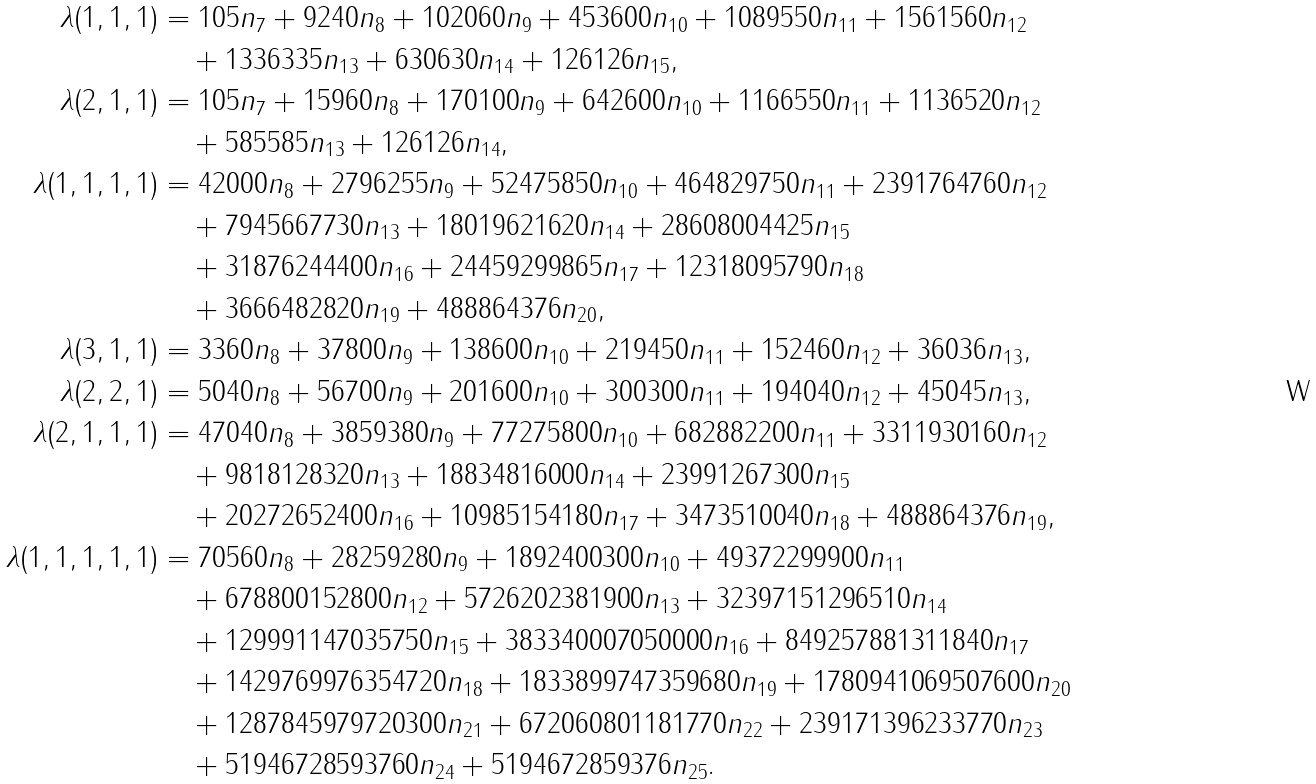Convert formula to latex. <formula><loc_0><loc_0><loc_500><loc_500>\lambda ( 1 , 1 , 1 ) & = 1 0 5 n _ { 7 } + 9 2 4 0 n _ { 8 } + 1 0 2 0 6 0 n _ { 9 } + 4 5 3 6 0 0 n _ { 1 0 } + 1 0 8 9 5 5 0 n _ { 1 1 } + 1 5 6 1 5 6 0 n _ { 1 2 } \\ & \quad + 1 3 3 6 3 3 5 n _ { 1 3 } + 6 3 0 6 3 0 n _ { 1 4 } + 1 2 6 1 2 6 n _ { 1 5 } , \\ \lambda ( 2 , 1 , 1 ) & = 1 0 5 n _ { 7 } + 1 5 9 6 0 n _ { 8 } + 1 7 0 1 0 0 n _ { 9 } + 6 4 2 6 0 0 n _ { 1 0 } + 1 1 6 6 5 5 0 n _ { 1 1 } + 1 1 3 6 5 2 0 n _ { 1 2 } \\ & \quad + 5 8 5 5 8 5 n _ { 1 3 } + 1 2 6 1 2 6 n _ { 1 4 } , \\ \lambda ( 1 , 1 , 1 , 1 ) & = 4 2 0 0 0 n _ { 8 } + 2 7 9 6 2 5 5 n _ { 9 } + 5 2 4 7 5 8 5 0 n _ { 1 0 } + 4 6 4 8 2 9 7 5 0 n _ { 1 1 } + 2 3 9 1 7 6 4 7 6 0 n _ { 1 2 } \\ & \quad + 7 9 4 5 6 6 7 7 3 0 n _ { 1 3 } + 1 8 0 1 9 6 2 1 6 2 0 n _ { 1 4 } + 2 8 6 0 8 0 0 4 4 2 5 n _ { 1 5 } \\ & \quad + 3 1 8 7 6 2 4 4 4 0 0 n _ { 1 6 } + 2 4 4 5 9 2 9 9 8 6 5 n _ { 1 7 } + 1 2 3 1 8 0 9 5 7 9 0 n _ { 1 8 } \\ & \quad + 3 6 6 6 4 8 2 8 2 0 n _ { 1 9 } + 4 8 8 8 6 4 3 7 6 n _ { 2 0 } , \\ \lambda ( 3 , 1 , 1 ) & = 3 3 6 0 n _ { 8 } + 3 7 8 0 0 n _ { 9 } + 1 3 8 6 0 0 n _ { 1 0 } + 2 1 9 4 5 0 n _ { 1 1 } + 1 5 2 4 6 0 n _ { 1 2 } + 3 6 0 3 6 n _ { 1 3 } , \\ \lambda ( 2 , 2 , 1 ) & = 5 0 4 0 n _ { 8 } + 5 6 7 0 0 n _ { 9 } + 2 0 1 6 0 0 n _ { 1 0 } + 3 0 0 3 0 0 n _ { 1 1 } + 1 9 4 0 4 0 n _ { 1 2 } + 4 5 0 4 5 n _ { 1 3 } , \\ \lambda ( 2 , 1 , 1 , 1 ) & = 4 7 0 4 0 n _ { 8 } + 3 8 5 9 3 8 0 n _ { 9 } + 7 7 2 7 5 8 0 0 n _ { 1 0 } + 6 8 2 8 8 2 2 0 0 n _ { 1 1 } + 3 3 1 1 9 3 0 1 6 0 n _ { 1 2 } \\ & \quad + 9 8 1 8 1 2 8 3 2 0 n _ { 1 3 } + 1 8 8 3 4 8 1 6 0 0 0 n _ { 1 4 } + 2 3 9 9 1 2 6 7 3 0 0 n _ { 1 5 } \\ & \quad + 2 0 2 7 2 6 5 2 4 0 0 n _ { 1 6 } + 1 0 9 8 5 1 5 4 1 8 0 n _ { 1 7 } + 3 4 7 3 5 1 0 0 4 0 n _ { 1 8 } + 4 8 8 8 6 4 3 7 6 n _ { 1 9 } , \\ \lambda ( 1 , 1 , 1 , 1 , 1 ) & = 7 0 5 6 0 n _ { 8 } + 2 8 2 5 9 2 8 0 n _ { 9 } + 1 8 9 2 4 0 0 3 0 0 n _ { 1 0 } + 4 9 3 7 2 2 9 9 9 0 0 n _ { 1 1 } \\ & \quad + 6 7 8 8 0 0 1 5 2 8 0 0 n _ { 1 2 } + 5 7 2 6 2 0 2 3 8 1 9 0 0 n _ { 1 3 } + 3 2 3 9 7 1 5 1 2 9 6 5 1 0 n _ { 1 4 } \\ & \quad + 1 2 9 9 9 1 1 4 7 0 3 5 7 5 0 n _ { 1 5 } + 3 8 3 3 4 0 0 0 7 0 5 0 0 0 0 n _ { 1 6 } + 8 4 9 2 5 7 8 8 1 3 1 1 8 4 0 n _ { 1 7 } \\ & \quad + 1 4 2 9 7 6 9 9 7 6 3 5 4 7 2 0 n _ { 1 8 } + 1 8 3 3 8 9 9 7 4 7 3 5 9 6 8 0 n _ { 1 9 } + 1 7 8 0 9 4 1 0 6 9 5 0 7 6 0 0 n _ { 2 0 } \\ & \quad + 1 2 8 7 8 4 5 9 7 9 7 2 0 3 0 0 n _ { 2 1 } + 6 7 2 0 6 0 8 0 1 1 8 1 7 7 0 n _ { 2 2 } + 2 3 9 1 7 1 3 9 6 2 3 3 7 7 0 n _ { 2 3 } \\ & \quad + 5 1 9 4 6 7 2 8 5 9 3 7 6 0 n _ { 2 4 } + 5 1 9 4 6 7 2 8 5 9 3 7 6 n _ { 2 5 } .</formula> 